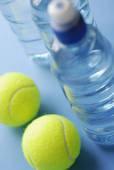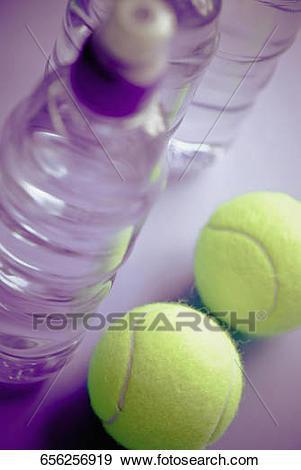The first image is the image on the left, the second image is the image on the right. Examine the images to the left and right. Is the description "There is at least one tennis ball near a water bottle." accurate? Answer yes or no. Yes. The first image is the image on the left, the second image is the image on the right. Evaluate the accuracy of this statement regarding the images: "At least one image includes a yellow tennis ball next to a water bottle.". Is it true? Answer yes or no. Yes. 